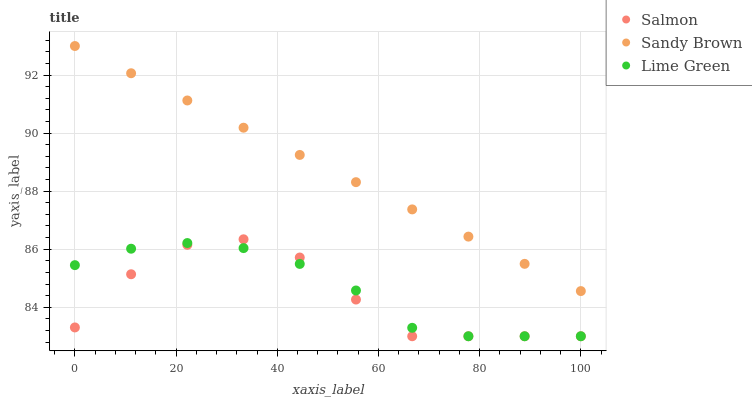Does Salmon have the minimum area under the curve?
Answer yes or no. Yes. Does Sandy Brown have the maximum area under the curve?
Answer yes or no. Yes. Does Lime Green have the minimum area under the curve?
Answer yes or no. No. Does Lime Green have the maximum area under the curve?
Answer yes or no. No. Is Sandy Brown the smoothest?
Answer yes or no. Yes. Is Salmon the roughest?
Answer yes or no. Yes. Is Lime Green the smoothest?
Answer yes or no. No. Is Lime Green the roughest?
Answer yes or no. No. Does Salmon have the lowest value?
Answer yes or no. Yes. Does Sandy Brown have the highest value?
Answer yes or no. Yes. Does Salmon have the highest value?
Answer yes or no. No. Is Salmon less than Sandy Brown?
Answer yes or no. Yes. Is Sandy Brown greater than Lime Green?
Answer yes or no. Yes. Does Lime Green intersect Salmon?
Answer yes or no. Yes. Is Lime Green less than Salmon?
Answer yes or no. No. Is Lime Green greater than Salmon?
Answer yes or no. No. Does Salmon intersect Sandy Brown?
Answer yes or no. No. 